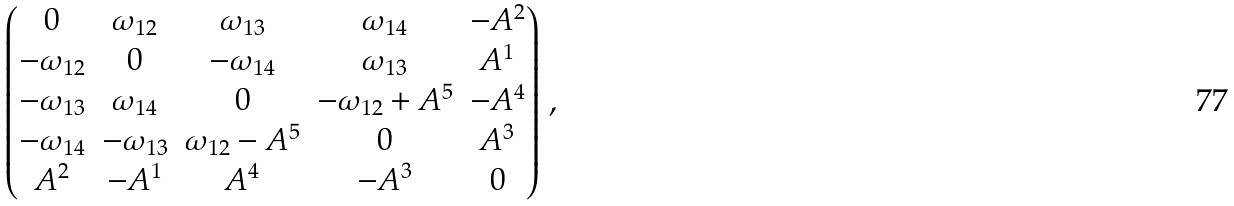<formula> <loc_0><loc_0><loc_500><loc_500>\begin{pmatrix} 0 & \omega _ { 1 2 } & \omega _ { 1 3 } & \omega _ { 1 4 } & - A ^ { 2 } \\ - \omega _ { 1 2 } & 0 & - \omega _ { 1 4 } & \omega _ { 1 3 } & A ^ { 1 } \\ - \omega _ { 1 3 } & \omega _ { 1 4 } & 0 & - \omega _ { 1 2 } + A ^ { 5 } & - A ^ { 4 } \\ - \omega _ { 1 4 } & - \omega _ { 1 3 } & \omega _ { 1 2 } - A ^ { 5 } & 0 & A ^ { 3 } \\ A ^ { 2 } & - A ^ { 1 } & A ^ { 4 } & - A ^ { 3 } & 0 \end{pmatrix} \, ,</formula> 